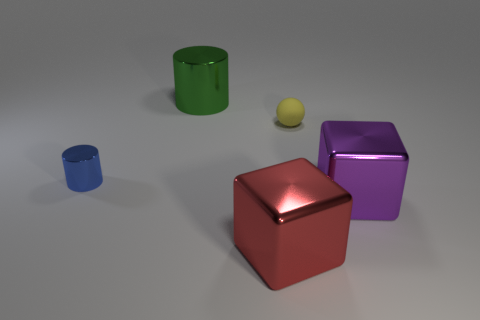Can you describe the arrangement of objects in this image? Certainly! In this image, we have an arrangement of geometric shapes. On the left, there's a small blue cylinder, and slightly in front of it lies a small yellow sphere. In the center, dominating the view is a large, reflective red cube. To the right of the red cube is a purple cube, which is slightly elevated above the ground, and further to the right, you will notice a larger green cylinder. 